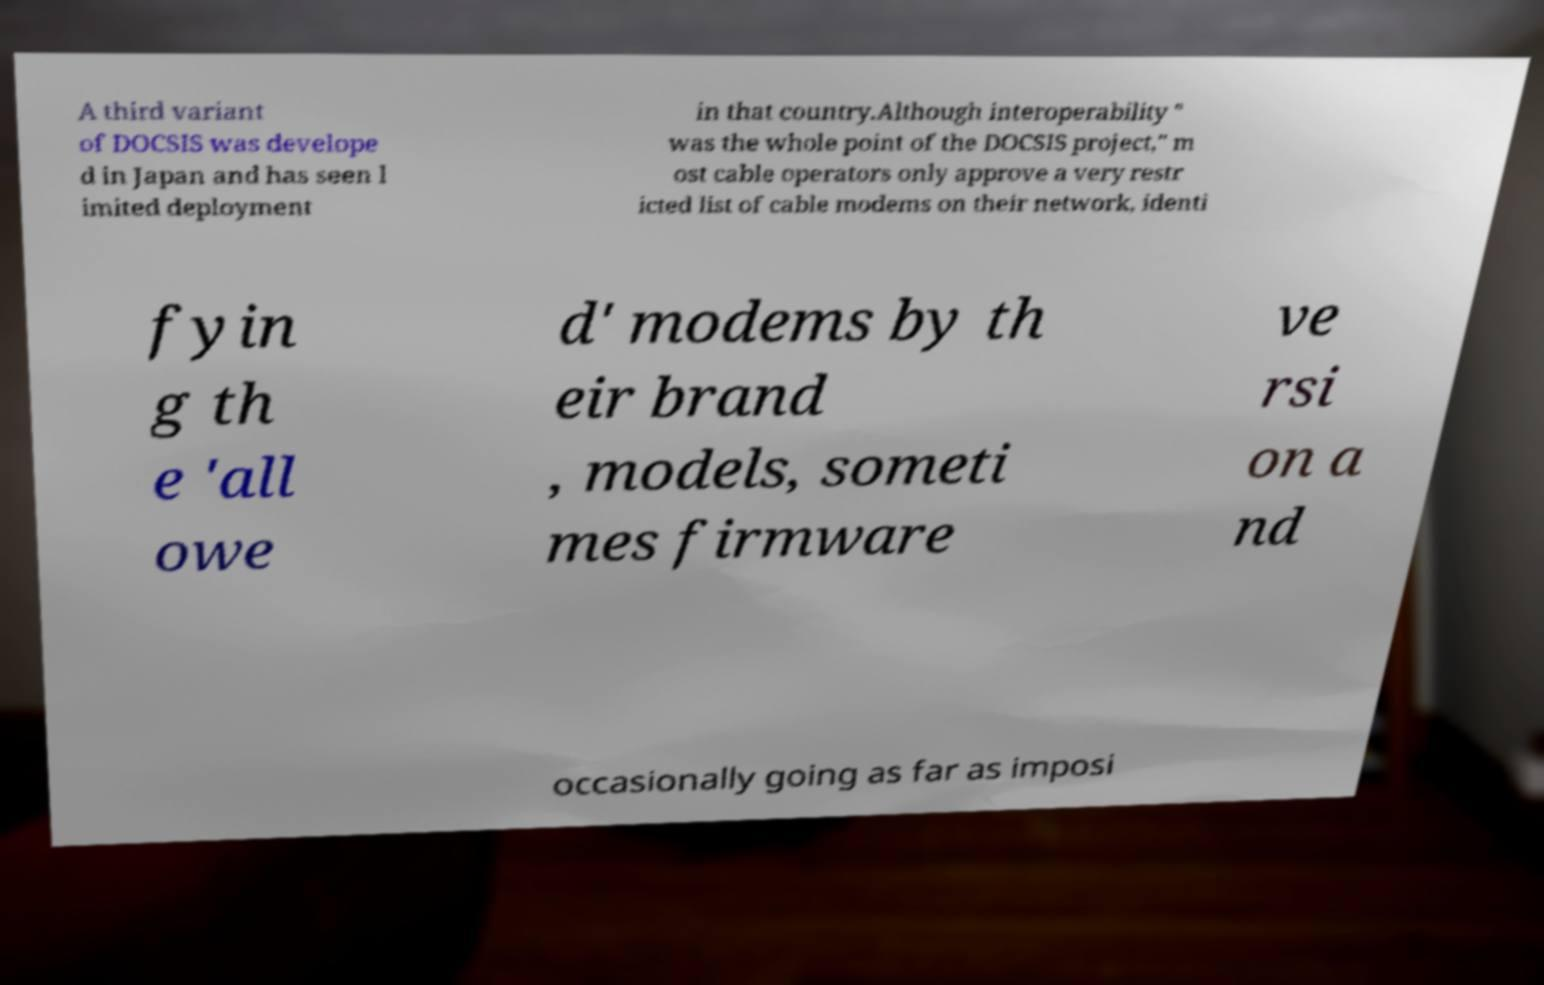Please identify and transcribe the text found in this image. A third variant of DOCSIS was develope d in Japan and has seen l imited deployment in that country.Although interoperability " was the whole point of the DOCSIS project," m ost cable operators only approve a very restr icted list of cable modems on their network, identi fyin g th e 'all owe d' modems by th eir brand , models, someti mes firmware ve rsi on a nd occasionally going as far as imposi 